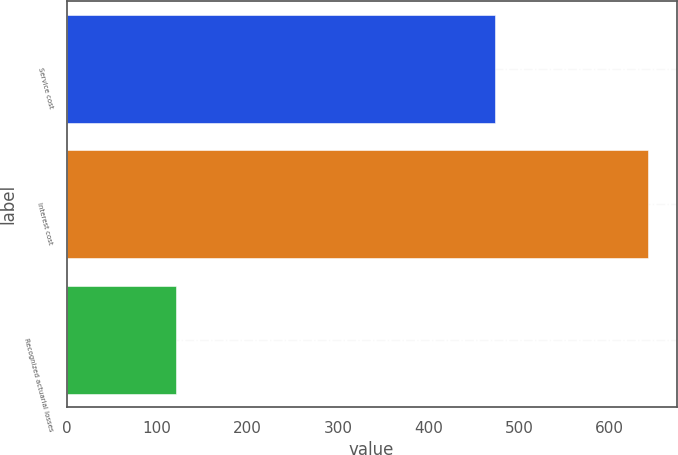<chart> <loc_0><loc_0><loc_500><loc_500><bar_chart><fcel>Service cost<fcel>Interest cost<fcel>Recognized actuarial losses<nl><fcel>473<fcel>642<fcel>121<nl></chart> 